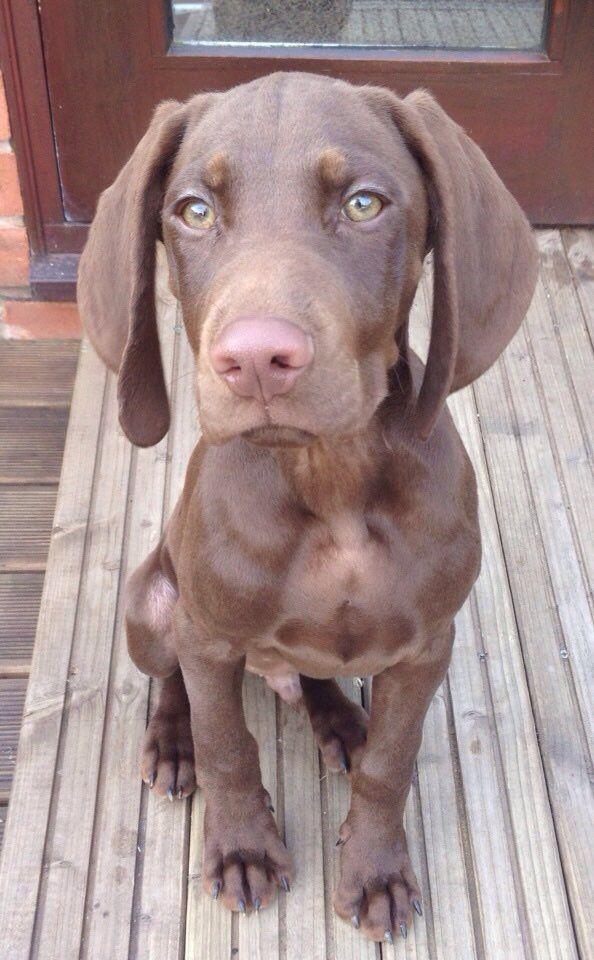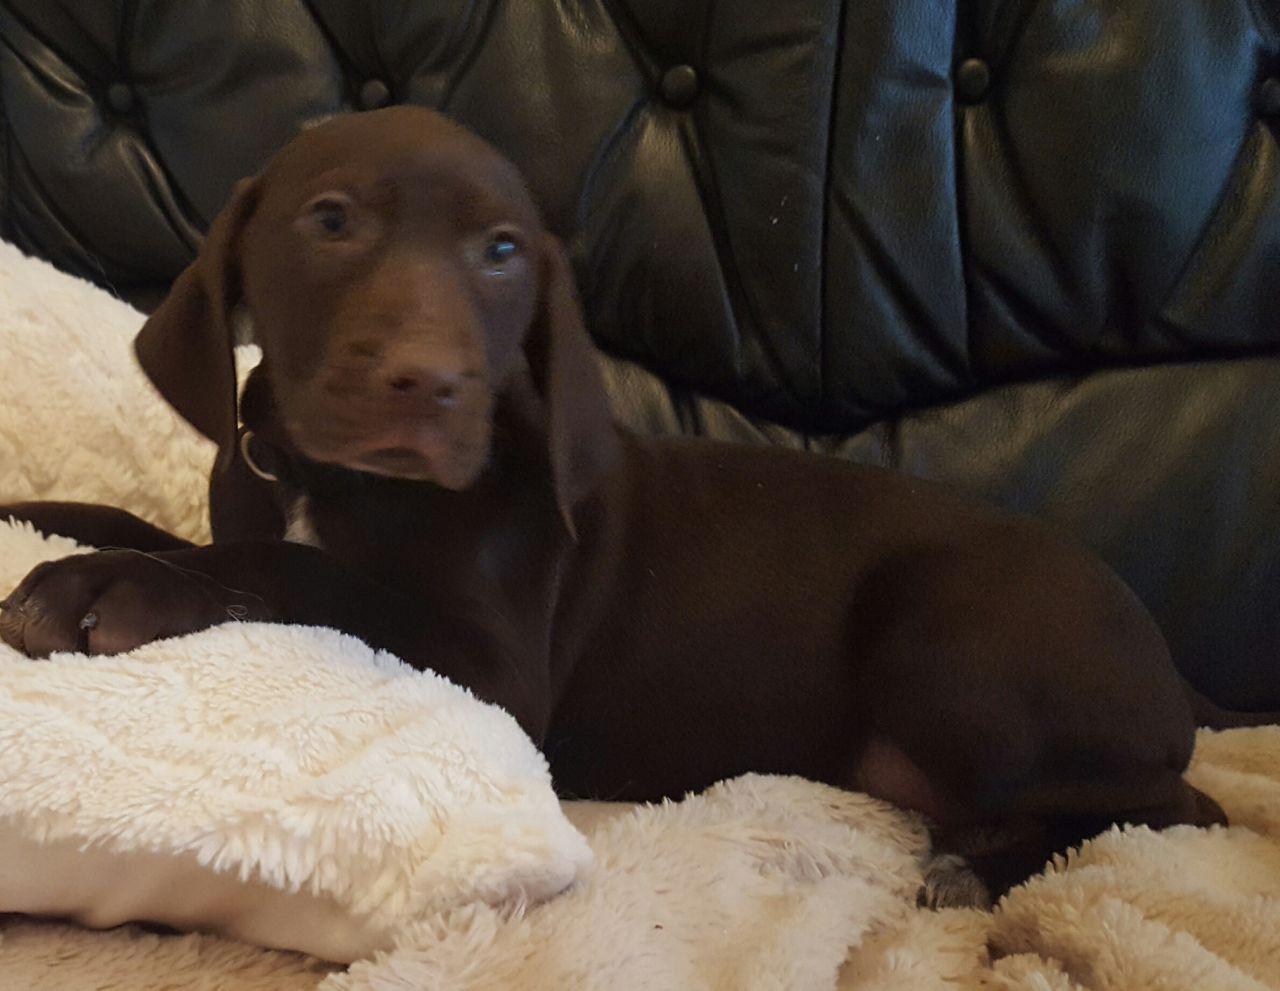The first image is the image on the left, the second image is the image on the right. Assess this claim about the two images: "A dog in one of the images is sitting on a wooden floor.". Correct or not? Answer yes or no. Yes. The first image is the image on the left, the second image is the image on the right. For the images shown, is this caption "One brown dog is sitting upright on a wood floor, and the other brown dog is reclining with its body in profile but its head turned to the camera." true? Answer yes or no. Yes. 